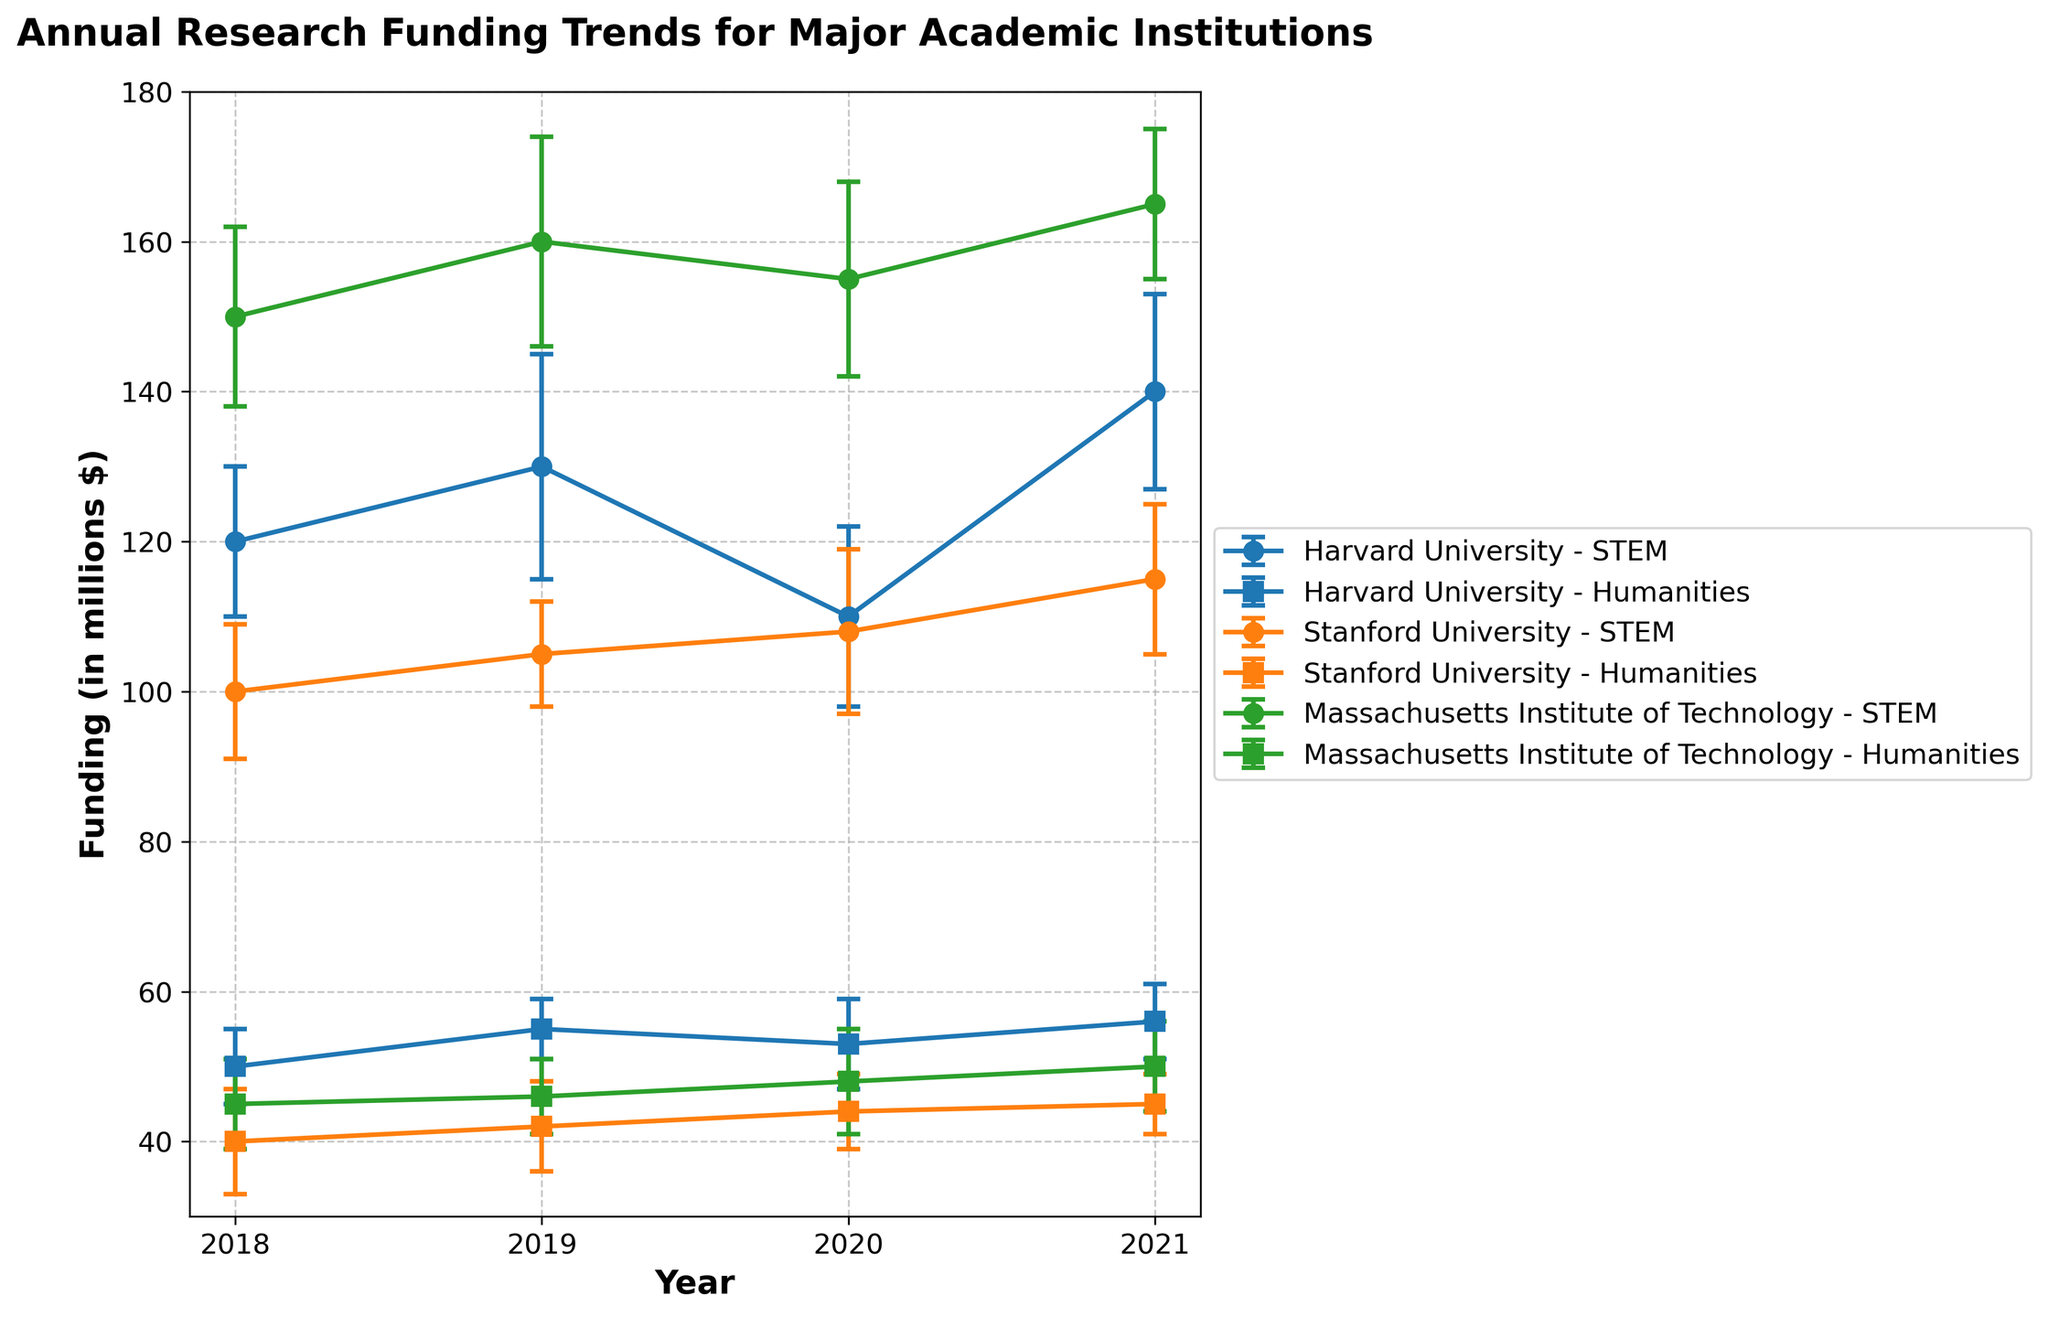Which institution has the highest STEM funding in 2021? Compare the funding levels for all institutions in the STEM category for the year 2021; MIT has the highest funding.
Answer: Massachusetts Institute of Technology What is the range in funding for humanities at Harvard University from 2018 to 2021? Subtract the lowest funding value from the highest for humanities at Harvard University in the given years (56 - 50).
Answer: 6 million dollars How does the trend of STEM funding at Stanford University from 2018 to 2021 compare to that of humanities? Look at the trend lines for STEM and humanities at Stanford University; STEM shows a steady increase, whereas humanities also shows a slight increase but at a smaller rate.
Answer: STEM funding increases steadily; humanities funding increases slightly Which department at MIT had more variation in funding over the years, STEM or humanities? Compare the error bars (representing standard deviation) in the line plots for STEM and humanities departments at MIT; STEM has larger error bars.
Answer: STEM Between which two consecutive years did STEM funding at Harvard University show the largest increase? Compare the differences in funding between consecutive years for STEM at Harvard University; the largest increase is between 2020 and 2021 (140 - 110).
Answer: 2020 and 2021 What is the average funding for humanities departments across all institutions in 2019? Sum the 2019 humanities funding for all institutions and divide by the number of institutions (55 + 42 + 46) / 3.
Answer: 47.67 million dollars Which institution had the lowest humanities funding in 2018? Compare the 2018 humanities funding levels of all institutions; Stanford University had the lowest funding.
Answer: Stanford University What is the overall trend for STEM funding at MIT from 2018 to 2021? Look at the line plot for MIT's STEM funding from 2018 to 2021; the funding shows an upward trend.
Answer: Upward trend Which year had the highest funding variability for humanities at Harvard University? Examine the length of the error bars for each year in the humanities department at Harvard University to find the largest; 2020 has the largest error bar.
Answer: 2020 